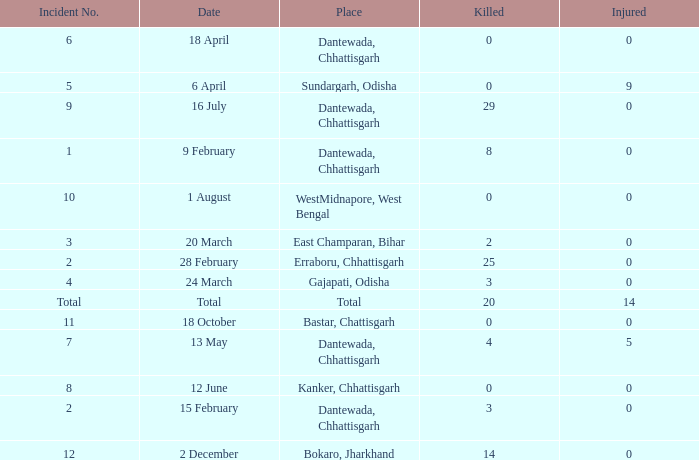What is the least amount of injuries in Dantewada, Chhattisgarh when 8 people were killed? 0.0. 